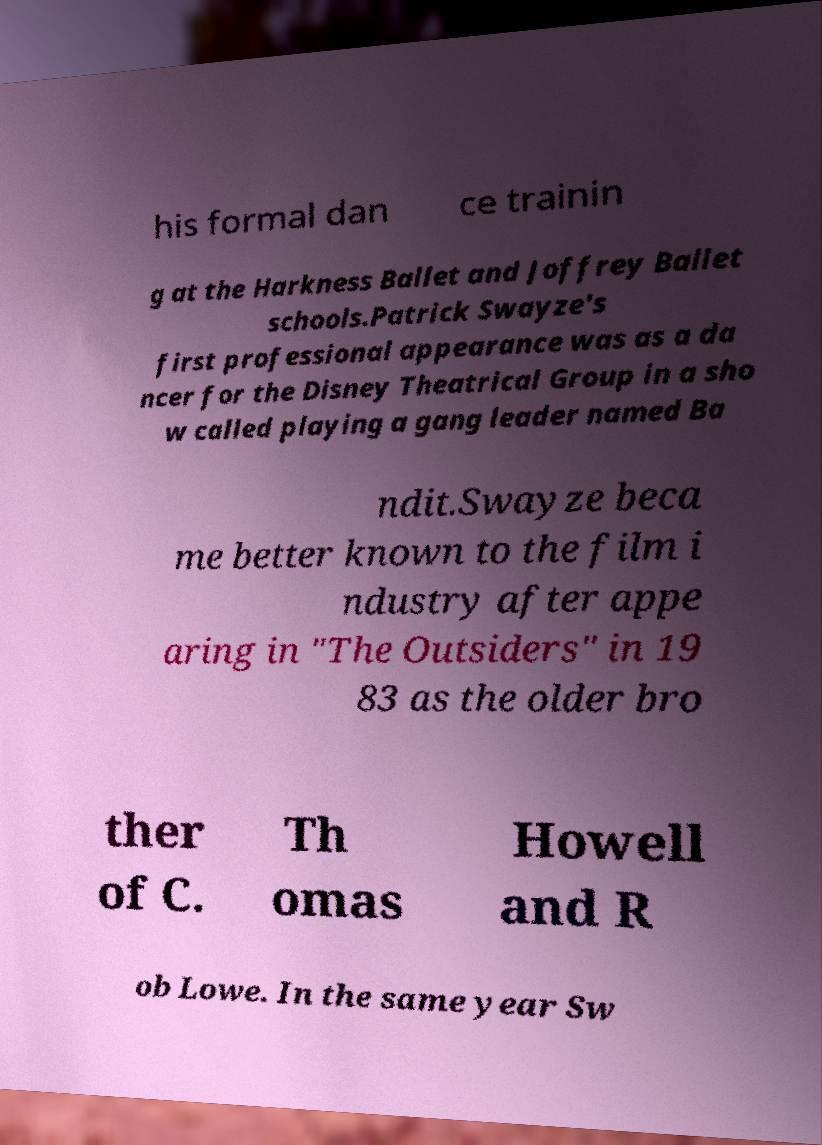For documentation purposes, I need the text within this image transcribed. Could you provide that? his formal dan ce trainin g at the Harkness Ballet and Joffrey Ballet schools.Patrick Swayze's first professional appearance was as a da ncer for the Disney Theatrical Group in a sho w called playing a gang leader named Ba ndit.Swayze beca me better known to the film i ndustry after appe aring in "The Outsiders" in 19 83 as the older bro ther of C. Th omas Howell and R ob Lowe. In the same year Sw 